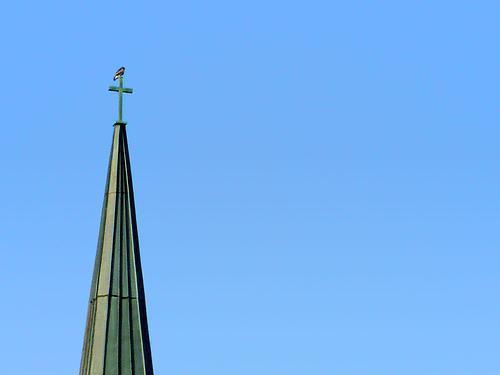How many airplanes are in the sky?
Give a very brief answer. 0. How many crosses do you see?
Give a very brief answer. 1. 